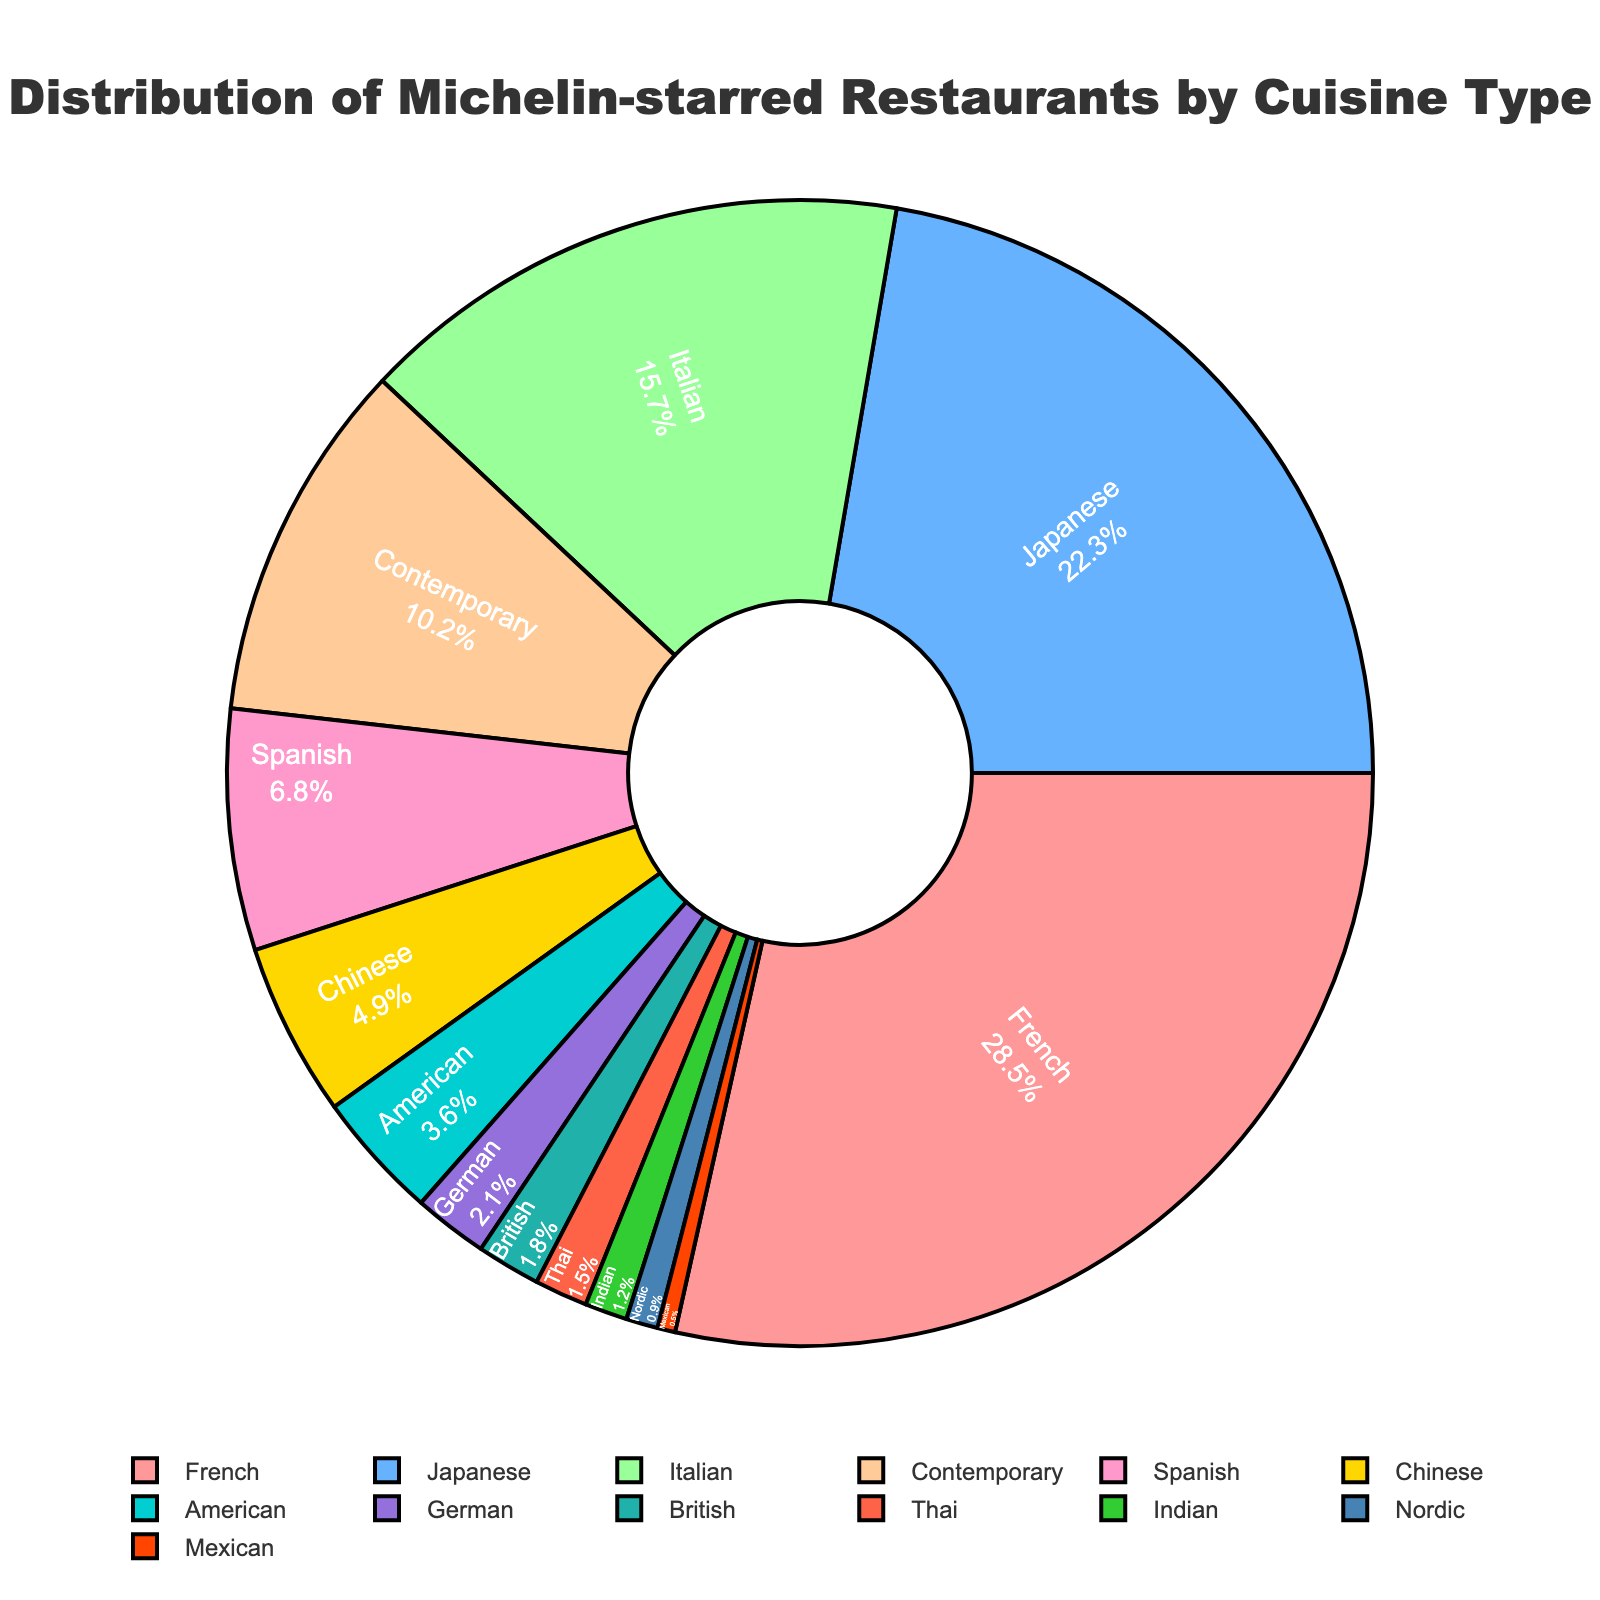what cuisine type accounts for the largest percentage of michelin-starred restaurants worldwide? The cuisine type with the largest percentage of Michelin-starred restaurants is the one with the highest value in the pie chart. Here, French cuisine has the highest value of 28.5%.
Answer: French Which two cuisine types together make up exactly half of the Michelin-starred restaurants? To find the two cuisine types that together make up exactly 50%, we need to add the percentages of various combinations until we find one that equals 50%. French (28.5%) and Japanese (22.3%) together make up 50.8%, which is the closest to half.
Answer: French and Japanese What is the percentage difference between Italian cuisine and American cuisine? To find the percentage difference between Italian and American cuisines, subtract the percentage of American cuisine from that of Italian cuisine. Italian (15.7%) - American (3.6%) = 12.1%.
Answer: 12.1% Which cuisine types have less than 5% representation? The pie chart shows us the percentages for each cuisine type, so we need to identify those with values less than 5%. These are Chinese (4.9%), American (3.6%), German (2.1%), British (1.8%), Thai (1.5%), Indian (1.2%), Nordic (0.9%), and Mexican (0.5%).
Answer: Chinese, American, German, British, Thai, Indian, Nordic, Mexican How many cuisine types are represented by more than 10%? Counting the sections of the pie chart that represent more than 10%, we see those are French (28.5%), Japanese (22.3%), Italian (15.7%), and Contemporary (10.2%). This means 4 cuisine types.
Answer: 4 If we combined the percentages of Contemporary and Spanish cuisines, would they surpass Italian cuisine? Adding the percentages for Contemporary (10.2%) and Spanish (6.8%), we get 17%. We need to see if this number is greater than the percentage for Italian cuisine (15.7%). 17% is greater than 15.7%.
Answer: Yes How does the representation of Chinese cuisine compare to that of Japanese cuisine? Comparing the percentages for Chinese cuisine (4.9%) and Japanese cuisine (22.3%), we see that Japanese cuisine has a much higher percentage.
Answer: Japanese cuisine is more represented By what margin does French cuisine lead over Spanish cuisine? To calculate the margin, subtract the percentage of Spanish cuisine (6.8%) from that of French cuisine (28.5%). 28.5% - 6.8% = 21.7%.
Answer: 21.7% Considering the colors used, what cuisine is represented by the green section on the pie chart? By identifying the unique colors for each cuisine type, and based on the color used for Nordic, we can assume the green section refers to Nordic.
Answer: Nordic What is the cumulative percentage of German, British, Thai, and Indian cuisines? Summing the percentages of German (2.1%), British (1.8%), Thai (1.5%), and Indian (1.2%) cuisines: 2.1% + 1.8% + 1.5% + 1.2% = 6.6%.
Answer: 6.6% 